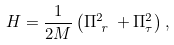<formula> <loc_0><loc_0><loc_500><loc_500>H = \frac { 1 } { 2 M } \left ( \Pi _ { \emph { r } } ^ { 2 } + \Pi _ { \tau } ^ { 2 } \right ) ,</formula> 